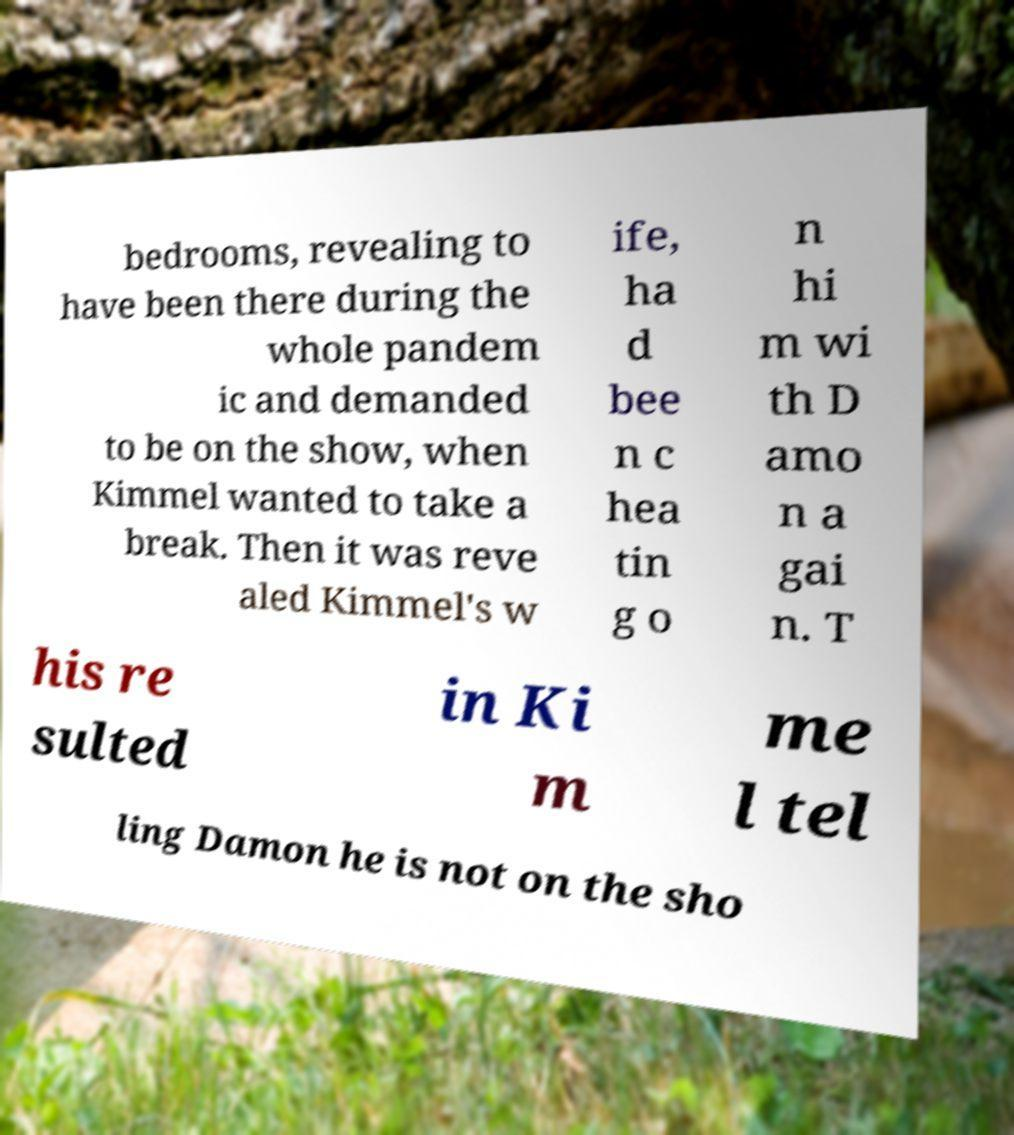Could you extract and type out the text from this image? bedrooms, revealing to have been there during the whole pandem ic and demanded to be on the show, when Kimmel wanted to take a break. Then it was reve aled Kimmel's w ife, ha d bee n c hea tin g o n hi m wi th D amo n a gai n. T his re sulted in Ki m me l tel ling Damon he is not on the sho 